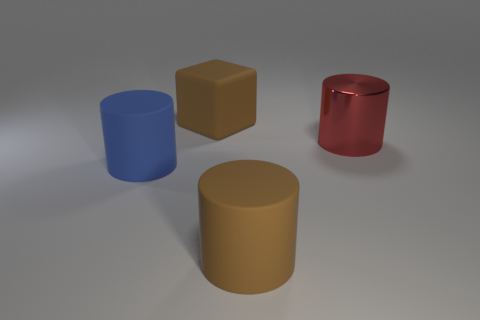Add 4 brown things. How many objects exist? 8 Subtract all cylinders. How many objects are left? 1 Subtract all large blue objects. Subtract all large brown rubber objects. How many objects are left? 1 Add 4 big metal things. How many big metal things are left? 5 Add 4 large blue objects. How many large blue objects exist? 5 Subtract 0 purple balls. How many objects are left? 4 